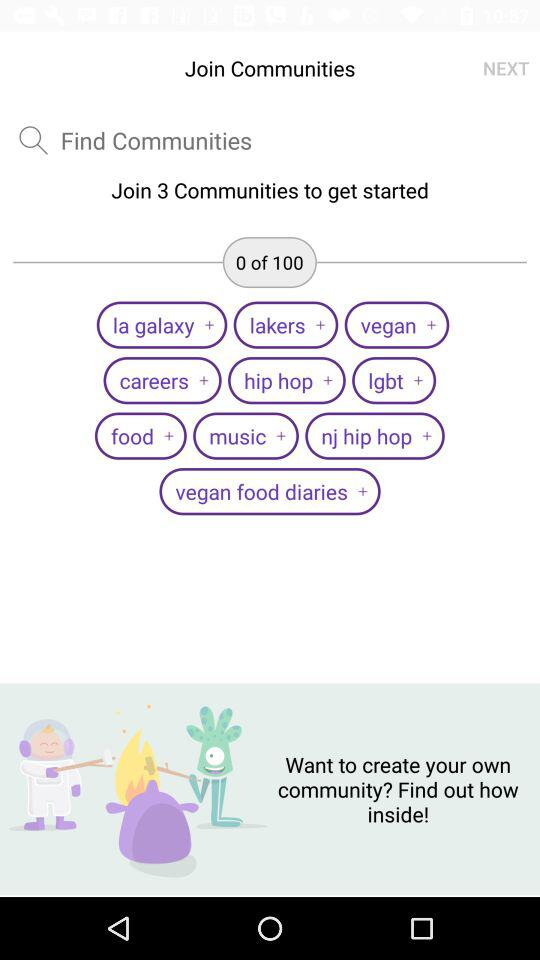How many communities in total do we have? You have 100 communities. 